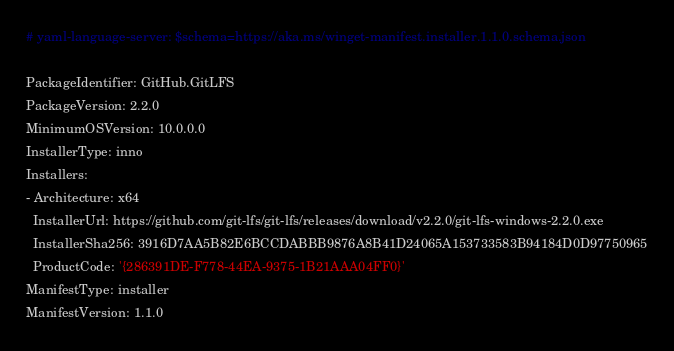<code> <loc_0><loc_0><loc_500><loc_500><_YAML_># yaml-language-server: $schema=https://aka.ms/winget-manifest.installer.1.1.0.schema.json

PackageIdentifier: GitHub.GitLFS
PackageVersion: 2.2.0
MinimumOSVersion: 10.0.0.0
InstallerType: inno
Installers:
- Architecture: x64
  InstallerUrl: https://github.com/git-lfs/git-lfs/releases/download/v2.2.0/git-lfs-windows-2.2.0.exe
  InstallerSha256: 3916D7AA5B82E6BCCDABBB9876A8B41D24065A153733583B94184D0D97750965
  ProductCode: '{286391DE-F778-44EA-9375-1B21AAA04FF0}'
ManifestType: installer
ManifestVersion: 1.1.0
</code> 